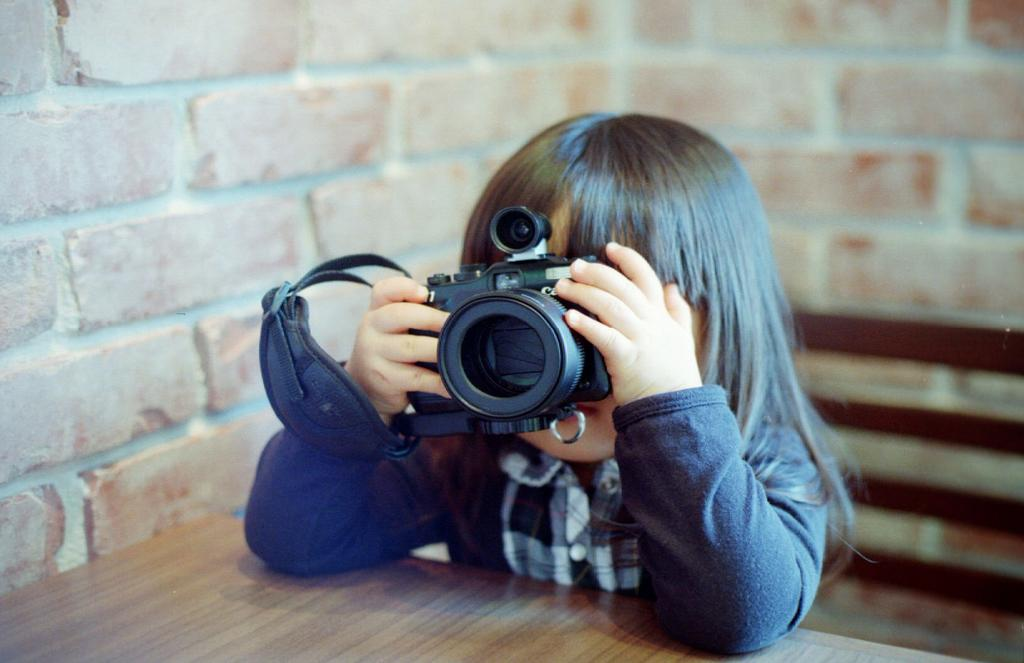Who is the main subject in the image? There is a small girl in the image. What is the girl holding in the image? The girl is holding a camera. What is the girl's position in the image? The girl is sitting. What type of furniture is present in the image? There is a wooden table in the image. What can be seen in the background of the image? There is a wall with bricks visible in the background. What type of playground equipment can be seen in the image? There is no playground equipment present in the image. What committee is the girl a part of in the image? There is no committee mentioned or depicted in the image. 